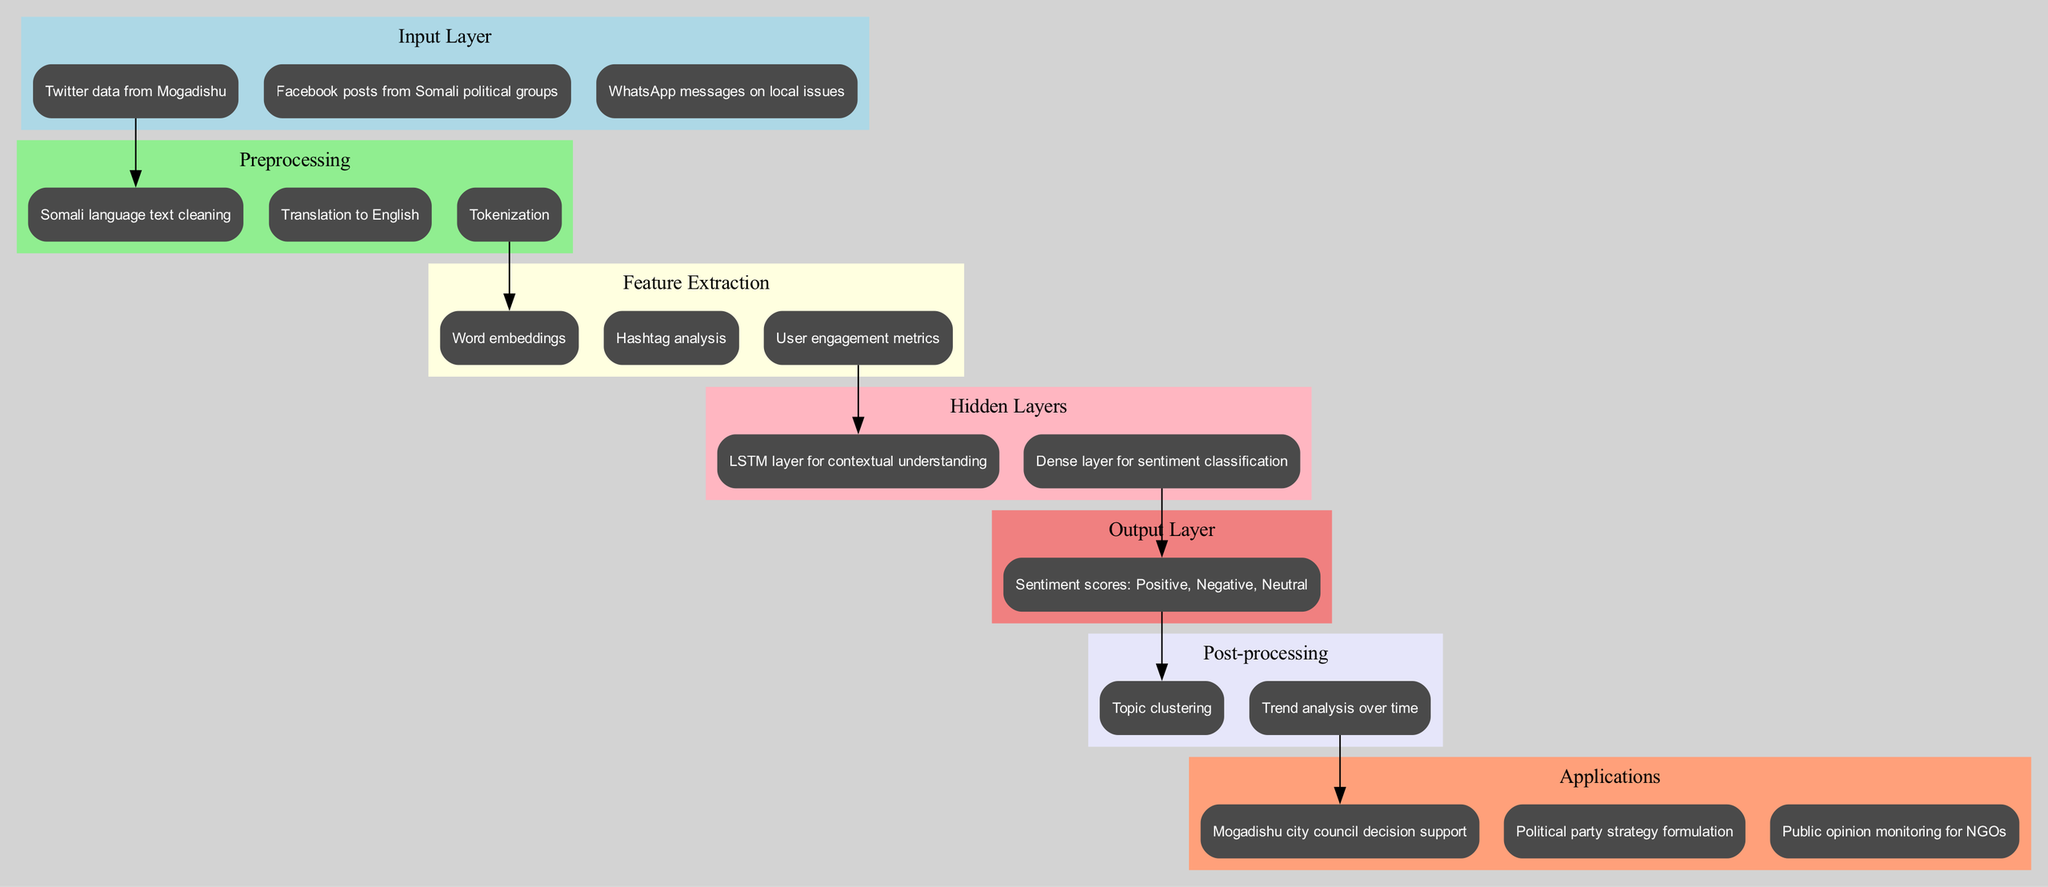What types of input data are used in the diagram? The diagram lists three distinct types of input data: Twitter data from Mogadishu, Facebook posts from Somali political groups, and WhatsApp messages on local issues. This can be found in the Input Layer section.
Answer: Twitter data from Mogadishu, Facebook posts from Somali political groups, WhatsApp messages on local issues How many preprocessing steps are included? By counting the nodes in the Preprocessing section, we see there are three distinct steps: Somali language text cleaning, Translation to English, and Tokenization.
Answer: 3 What is the main function of the Hidden Layers? The Hidden Layers consist of two essential components, an LSTM layer for contextual understanding and a Dense layer for sentiment classification. Their combination allows the network to analyze and classify sentiments effectively.
Answer: Sentiment classification Which preprocessing step directly leads to feature extraction? The preprocessing step of Translation to English directs data flow to the Feature Extraction stage, specifically to the Word embeddings node. This step prepares processed text for further analysis of useful features.
Answer: Translation to English What are the outputs of this neural network architecture? The Output Layer identifies sentiment scores which comprise Positive, Negative, and Neutral classifications, summarizing the sentiment derived from the analyzed data.
Answer: Sentiment scores: Positive, Negative, Neutral How many applications are listed in the diagram? The Applications section displays three specific applications: Mogadishu city council decision support, Political party strategy formulation, and Public opinion monitoring for NGOs, which indicates the potential uses of analyzed sentiment data.
Answer: 3 Which feature extraction method analyzes user engagement? The diagram specifies that User engagement metrics are part of the Feature Extraction methods, emphasizing that understanding user interaction is crucial for sentiment analysis.
Answer: User engagement metrics What is the connection between the output and post-processing layers? The diagram shows a direct edge from the Output Layer node indicating sentiment scores to the post-processing node for Topic clustering, indicating that the output sentiments influence subsequent analysis.
Answer: Sentiment scores to Topic clustering What is the purpose of the post-processing stage in this architecture? Post-processing includes Topic clustering and Trend analysis over time, which allows for further interpretation of sentiment data and understanding how sentiments evolve, enabling better insights for local political issues.
Answer: Topic clustering, Trend analysis over time 